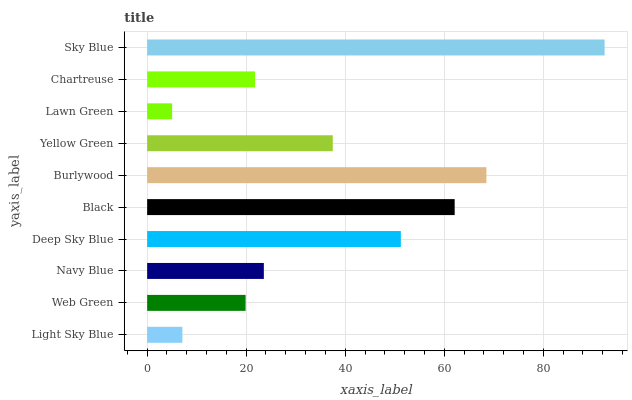Is Lawn Green the minimum?
Answer yes or no. Yes. Is Sky Blue the maximum?
Answer yes or no. Yes. Is Web Green the minimum?
Answer yes or no. No. Is Web Green the maximum?
Answer yes or no. No. Is Web Green greater than Light Sky Blue?
Answer yes or no. Yes. Is Light Sky Blue less than Web Green?
Answer yes or no. Yes. Is Light Sky Blue greater than Web Green?
Answer yes or no. No. Is Web Green less than Light Sky Blue?
Answer yes or no. No. Is Yellow Green the high median?
Answer yes or no. Yes. Is Navy Blue the low median?
Answer yes or no. Yes. Is Web Green the high median?
Answer yes or no. No. Is Black the low median?
Answer yes or no. No. 